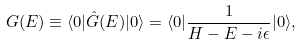Convert formula to latex. <formula><loc_0><loc_0><loc_500><loc_500>G ( E ) \equiv \langle 0 | \hat { G } ( E ) | 0 \rangle = \langle 0 | \frac { 1 } { H - E - i \epsilon } | 0 \rangle ,</formula> 